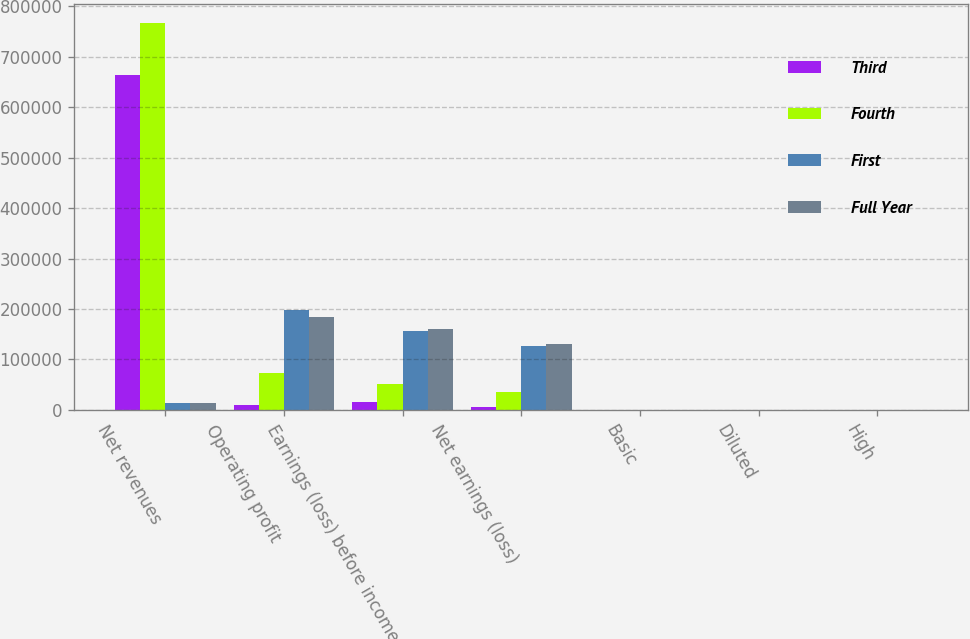<chart> <loc_0><loc_0><loc_500><loc_500><stacked_bar_chart><ecel><fcel>Net revenues<fcel>Operating profit<fcel>Earnings (loss) before income<fcel>Net earnings (loss)<fcel>Basic<fcel>Diluted<fcel>High<nl><fcel>Third<fcel>663694<fcel>10627<fcel>16493<fcel>6671<fcel>0.05<fcel>0.05<fcel>44.14<nl><fcel>Fourth<fcel>766342<fcel>74088<fcel>51076<fcel>36480<fcel>0.28<fcel>0.28<fcel>48.97<nl><fcel>First<fcel>13560<fcel>198706<fcel>155913<fcel>126574<fcel>0.97<fcel>0.96<fcel>49.75<nl><fcel>Full Year<fcel>13560<fcel>183672<fcel>161326<fcel>129815<fcel>0.99<fcel>0.98<fcel>54.55<nl></chart> 